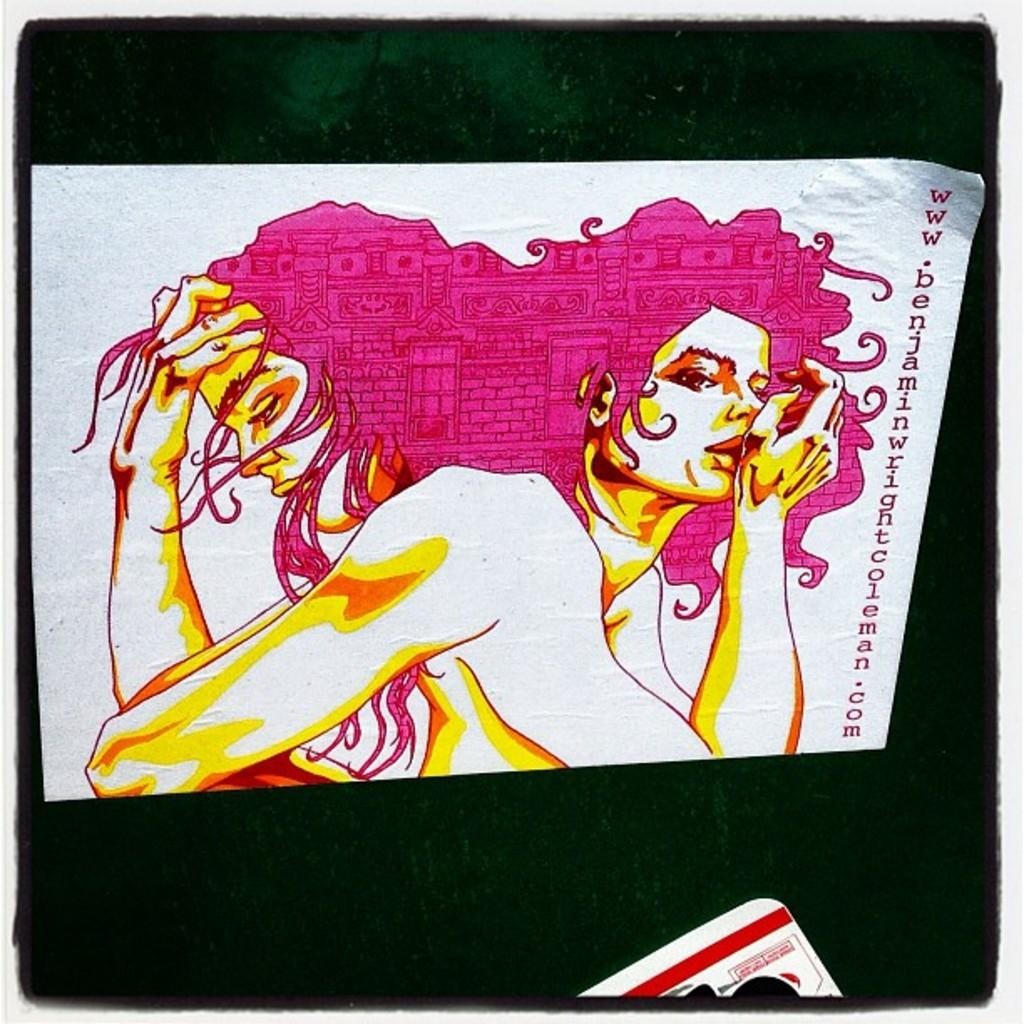What medium is used for the artwork in the image? The image is a painting on paper. What color is used for the background of the painting? The background of the painting is black. What type of truck is depicted in the painting? There is no truck present in the painting; it is a painting on paper with a black background. What type of beetle can be seen crawling on the painting? There is no beetle present in the painting; it is a painting on paper with a black background. 